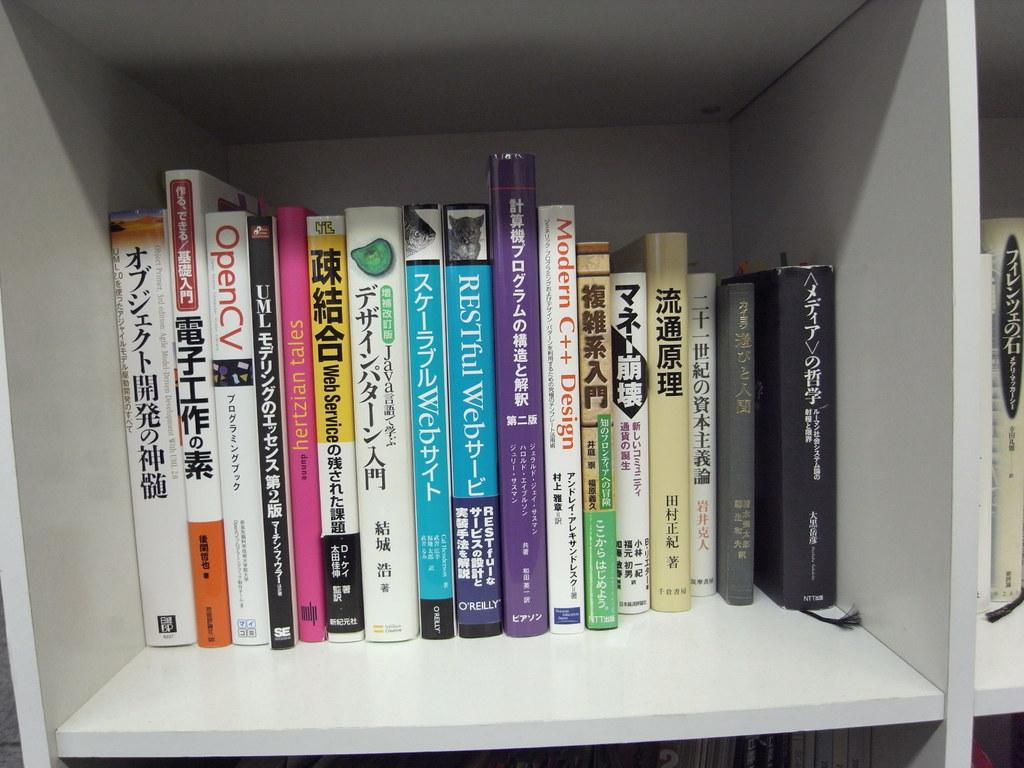<image>
Provide a brief description of the given image. Restful web and other books sitting near each other 